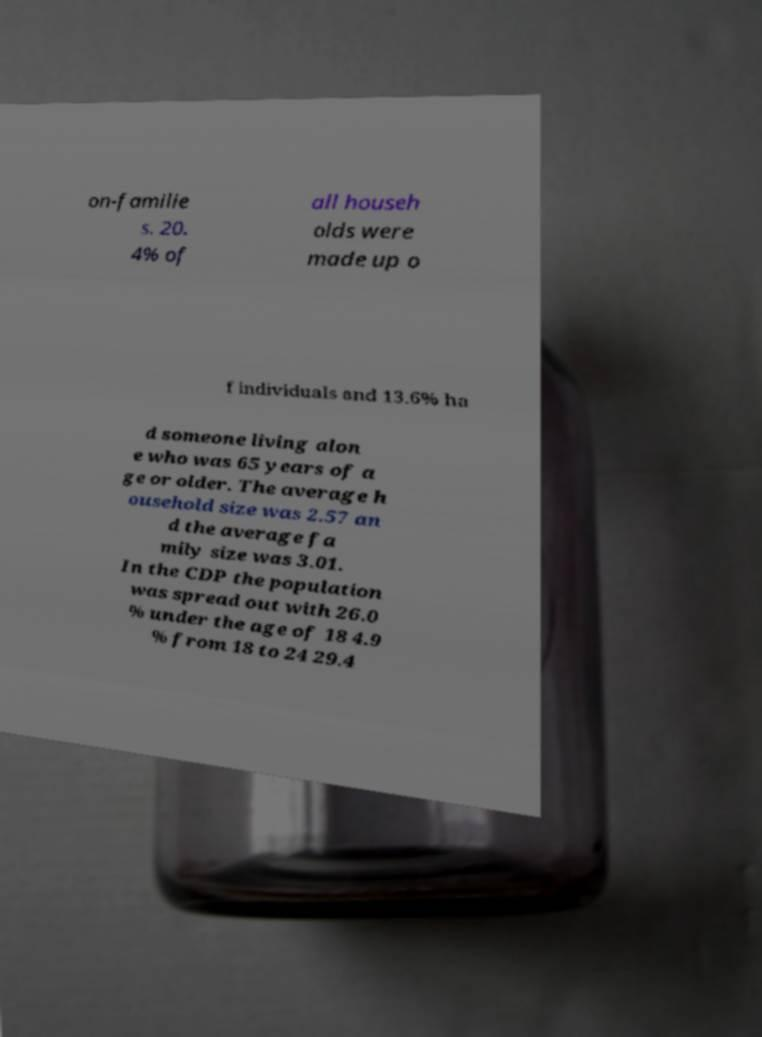There's text embedded in this image that I need extracted. Can you transcribe it verbatim? on-familie s. 20. 4% of all househ olds were made up o f individuals and 13.6% ha d someone living alon e who was 65 years of a ge or older. The average h ousehold size was 2.57 an d the average fa mily size was 3.01. In the CDP the population was spread out with 26.0 % under the age of 18 4.9 % from 18 to 24 29.4 